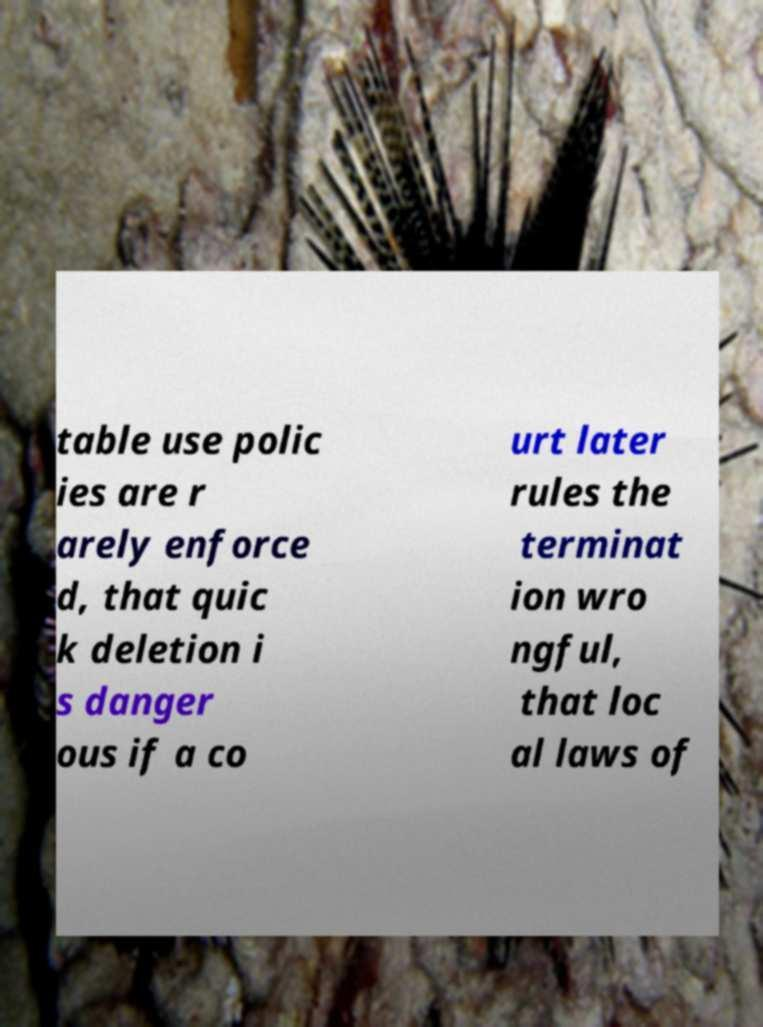There's text embedded in this image that I need extracted. Can you transcribe it verbatim? table use polic ies are r arely enforce d, that quic k deletion i s danger ous if a co urt later rules the terminat ion wro ngful, that loc al laws of 